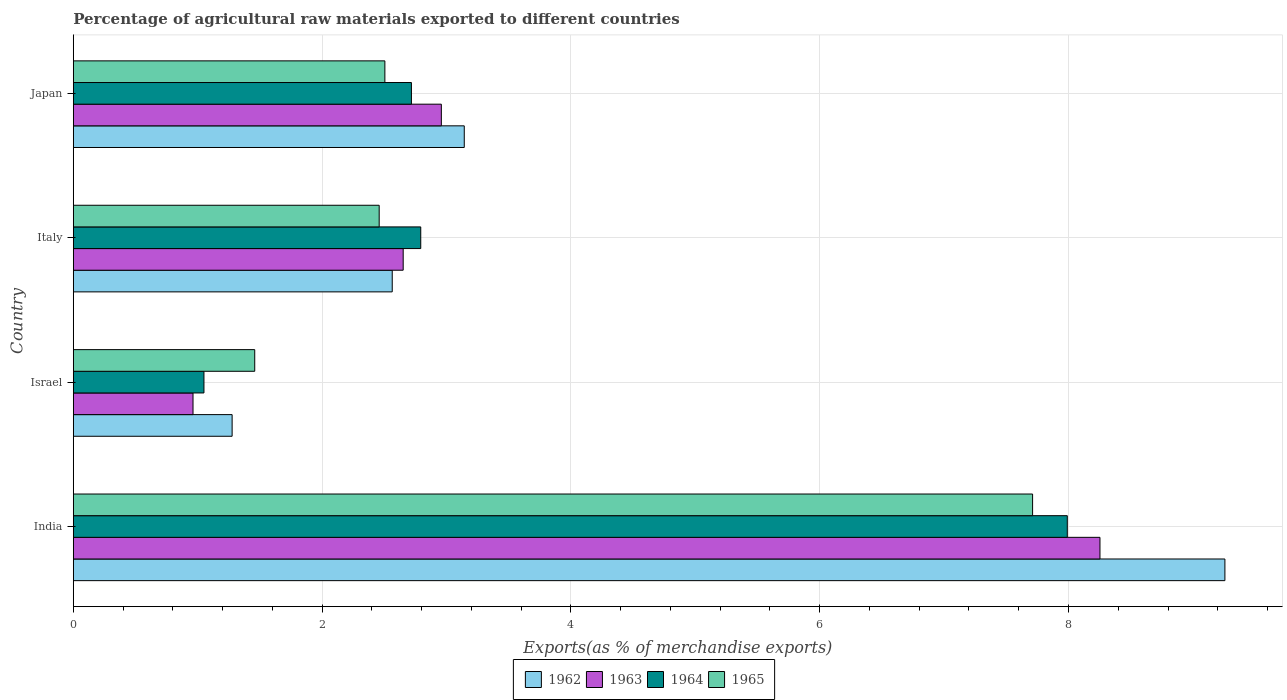How many groups of bars are there?
Give a very brief answer. 4. Are the number of bars on each tick of the Y-axis equal?
Your response must be concise. Yes. What is the label of the 2nd group of bars from the top?
Keep it short and to the point. Italy. What is the percentage of exports to different countries in 1964 in Israel?
Your answer should be compact. 1.05. Across all countries, what is the maximum percentage of exports to different countries in 1965?
Your answer should be very brief. 7.71. Across all countries, what is the minimum percentage of exports to different countries in 1963?
Provide a short and direct response. 0.96. In which country was the percentage of exports to different countries in 1964 maximum?
Offer a terse response. India. In which country was the percentage of exports to different countries in 1963 minimum?
Your answer should be very brief. Israel. What is the total percentage of exports to different countries in 1962 in the graph?
Your response must be concise. 16.24. What is the difference between the percentage of exports to different countries in 1965 in Israel and that in Italy?
Your response must be concise. -1. What is the difference between the percentage of exports to different countries in 1963 in Japan and the percentage of exports to different countries in 1962 in Israel?
Ensure brevity in your answer.  1.68. What is the average percentage of exports to different countries in 1964 per country?
Provide a succinct answer. 3.64. What is the difference between the percentage of exports to different countries in 1963 and percentage of exports to different countries in 1964 in India?
Provide a short and direct response. 0.26. In how many countries, is the percentage of exports to different countries in 1964 greater than 8.4 %?
Your response must be concise. 0. What is the ratio of the percentage of exports to different countries in 1964 in Israel to that in Italy?
Your answer should be very brief. 0.38. Is the difference between the percentage of exports to different countries in 1963 in Italy and Japan greater than the difference between the percentage of exports to different countries in 1964 in Italy and Japan?
Offer a terse response. No. What is the difference between the highest and the second highest percentage of exports to different countries in 1964?
Give a very brief answer. 5.2. What is the difference between the highest and the lowest percentage of exports to different countries in 1962?
Your answer should be compact. 7.98. In how many countries, is the percentage of exports to different countries in 1962 greater than the average percentage of exports to different countries in 1962 taken over all countries?
Provide a short and direct response. 1. Is the sum of the percentage of exports to different countries in 1963 in India and Israel greater than the maximum percentage of exports to different countries in 1964 across all countries?
Keep it short and to the point. Yes. What does the 2nd bar from the top in Japan represents?
Provide a short and direct response. 1964. Is it the case that in every country, the sum of the percentage of exports to different countries in 1963 and percentage of exports to different countries in 1964 is greater than the percentage of exports to different countries in 1965?
Keep it short and to the point. Yes. Are all the bars in the graph horizontal?
Ensure brevity in your answer.  Yes. How many countries are there in the graph?
Your response must be concise. 4. What is the difference between two consecutive major ticks on the X-axis?
Provide a succinct answer. 2. Does the graph contain any zero values?
Offer a very short reply. No. Where does the legend appear in the graph?
Make the answer very short. Bottom center. How many legend labels are there?
Ensure brevity in your answer.  4. What is the title of the graph?
Keep it short and to the point. Percentage of agricultural raw materials exported to different countries. Does "1985" appear as one of the legend labels in the graph?
Your response must be concise. No. What is the label or title of the X-axis?
Give a very brief answer. Exports(as % of merchandise exports). What is the Exports(as % of merchandise exports) in 1962 in India?
Make the answer very short. 9.26. What is the Exports(as % of merchandise exports) of 1963 in India?
Your answer should be compact. 8.25. What is the Exports(as % of merchandise exports) of 1964 in India?
Your answer should be compact. 7.99. What is the Exports(as % of merchandise exports) of 1965 in India?
Offer a terse response. 7.71. What is the Exports(as % of merchandise exports) in 1962 in Israel?
Make the answer very short. 1.28. What is the Exports(as % of merchandise exports) of 1963 in Israel?
Your answer should be compact. 0.96. What is the Exports(as % of merchandise exports) in 1964 in Israel?
Offer a very short reply. 1.05. What is the Exports(as % of merchandise exports) in 1965 in Israel?
Offer a terse response. 1.46. What is the Exports(as % of merchandise exports) of 1962 in Italy?
Offer a very short reply. 2.56. What is the Exports(as % of merchandise exports) of 1963 in Italy?
Keep it short and to the point. 2.65. What is the Exports(as % of merchandise exports) in 1964 in Italy?
Keep it short and to the point. 2.79. What is the Exports(as % of merchandise exports) in 1965 in Italy?
Provide a succinct answer. 2.46. What is the Exports(as % of merchandise exports) in 1962 in Japan?
Offer a very short reply. 3.14. What is the Exports(as % of merchandise exports) of 1963 in Japan?
Keep it short and to the point. 2.96. What is the Exports(as % of merchandise exports) in 1964 in Japan?
Give a very brief answer. 2.72. What is the Exports(as % of merchandise exports) of 1965 in Japan?
Make the answer very short. 2.5. Across all countries, what is the maximum Exports(as % of merchandise exports) in 1962?
Your answer should be very brief. 9.26. Across all countries, what is the maximum Exports(as % of merchandise exports) of 1963?
Your response must be concise. 8.25. Across all countries, what is the maximum Exports(as % of merchandise exports) of 1964?
Make the answer very short. 7.99. Across all countries, what is the maximum Exports(as % of merchandise exports) in 1965?
Make the answer very short. 7.71. Across all countries, what is the minimum Exports(as % of merchandise exports) of 1962?
Your response must be concise. 1.28. Across all countries, what is the minimum Exports(as % of merchandise exports) in 1963?
Your response must be concise. 0.96. Across all countries, what is the minimum Exports(as % of merchandise exports) of 1964?
Provide a succinct answer. 1.05. Across all countries, what is the minimum Exports(as % of merchandise exports) in 1965?
Ensure brevity in your answer.  1.46. What is the total Exports(as % of merchandise exports) of 1962 in the graph?
Offer a terse response. 16.24. What is the total Exports(as % of merchandise exports) in 1963 in the graph?
Make the answer very short. 14.83. What is the total Exports(as % of merchandise exports) in 1964 in the graph?
Your response must be concise. 14.55. What is the total Exports(as % of merchandise exports) in 1965 in the graph?
Ensure brevity in your answer.  14.13. What is the difference between the Exports(as % of merchandise exports) of 1962 in India and that in Israel?
Ensure brevity in your answer.  7.98. What is the difference between the Exports(as % of merchandise exports) in 1963 in India and that in Israel?
Offer a very short reply. 7.29. What is the difference between the Exports(as % of merchandise exports) in 1964 in India and that in Israel?
Offer a terse response. 6.94. What is the difference between the Exports(as % of merchandise exports) of 1965 in India and that in Israel?
Offer a terse response. 6.25. What is the difference between the Exports(as % of merchandise exports) of 1962 in India and that in Italy?
Make the answer very short. 6.69. What is the difference between the Exports(as % of merchandise exports) in 1963 in India and that in Italy?
Ensure brevity in your answer.  5.6. What is the difference between the Exports(as % of merchandise exports) in 1964 in India and that in Italy?
Offer a terse response. 5.2. What is the difference between the Exports(as % of merchandise exports) in 1965 in India and that in Italy?
Give a very brief answer. 5.25. What is the difference between the Exports(as % of merchandise exports) of 1962 in India and that in Japan?
Provide a succinct answer. 6.11. What is the difference between the Exports(as % of merchandise exports) of 1963 in India and that in Japan?
Keep it short and to the point. 5.29. What is the difference between the Exports(as % of merchandise exports) of 1964 in India and that in Japan?
Make the answer very short. 5.27. What is the difference between the Exports(as % of merchandise exports) in 1965 in India and that in Japan?
Your response must be concise. 5.21. What is the difference between the Exports(as % of merchandise exports) of 1962 in Israel and that in Italy?
Offer a very short reply. -1.29. What is the difference between the Exports(as % of merchandise exports) of 1963 in Israel and that in Italy?
Provide a short and direct response. -1.69. What is the difference between the Exports(as % of merchandise exports) in 1964 in Israel and that in Italy?
Offer a very short reply. -1.74. What is the difference between the Exports(as % of merchandise exports) in 1965 in Israel and that in Italy?
Keep it short and to the point. -1. What is the difference between the Exports(as % of merchandise exports) in 1962 in Israel and that in Japan?
Offer a terse response. -1.87. What is the difference between the Exports(as % of merchandise exports) of 1963 in Israel and that in Japan?
Ensure brevity in your answer.  -2. What is the difference between the Exports(as % of merchandise exports) of 1964 in Israel and that in Japan?
Provide a short and direct response. -1.67. What is the difference between the Exports(as % of merchandise exports) in 1965 in Israel and that in Japan?
Provide a short and direct response. -1.05. What is the difference between the Exports(as % of merchandise exports) of 1962 in Italy and that in Japan?
Your response must be concise. -0.58. What is the difference between the Exports(as % of merchandise exports) in 1963 in Italy and that in Japan?
Give a very brief answer. -0.31. What is the difference between the Exports(as % of merchandise exports) in 1964 in Italy and that in Japan?
Make the answer very short. 0.07. What is the difference between the Exports(as % of merchandise exports) in 1965 in Italy and that in Japan?
Provide a short and direct response. -0.05. What is the difference between the Exports(as % of merchandise exports) of 1962 in India and the Exports(as % of merchandise exports) of 1963 in Israel?
Give a very brief answer. 8.3. What is the difference between the Exports(as % of merchandise exports) of 1962 in India and the Exports(as % of merchandise exports) of 1964 in Israel?
Offer a very short reply. 8.21. What is the difference between the Exports(as % of merchandise exports) of 1962 in India and the Exports(as % of merchandise exports) of 1965 in Israel?
Make the answer very short. 7.8. What is the difference between the Exports(as % of merchandise exports) of 1963 in India and the Exports(as % of merchandise exports) of 1964 in Israel?
Your response must be concise. 7.2. What is the difference between the Exports(as % of merchandise exports) of 1963 in India and the Exports(as % of merchandise exports) of 1965 in Israel?
Make the answer very short. 6.79. What is the difference between the Exports(as % of merchandise exports) in 1964 in India and the Exports(as % of merchandise exports) in 1965 in Israel?
Ensure brevity in your answer.  6.53. What is the difference between the Exports(as % of merchandise exports) of 1962 in India and the Exports(as % of merchandise exports) of 1963 in Italy?
Your answer should be compact. 6.61. What is the difference between the Exports(as % of merchandise exports) in 1962 in India and the Exports(as % of merchandise exports) in 1964 in Italy?
Offer a terse response. 6.46. What is the difference between the Exports(as % of merchandise exports) of 1962 in India and the Exports(as % of merchandise exports) of 1965 in Italy?
Keep it short and to the point. 6.8. What is the difference between the Exports(as % of merchandise exports) in 1963 in India and the Exports(as % of merchandise exports) in 1964 in Italy?
Provide a short and direct response. 5.46. What is the difference between the Exports(as % of merchandise exports) in 1963 in India and the Exports(as % of merchandise exports) in 1965 in Italy?
Offer a very short reply. 5.79. What is the difference between the Exports(as % of merchandise exports) in 1964 in India and the Exports(as % of merchandise exports) in 1965 in Italy?
Your answer should be compact. 5.53. What is the difference between the Exports(as % of merchandise exports) in 1962 in India and the Exports(as % of merchandise exports) in 1963 in Japan?
Provide a short and direct response. 6.3. What is the difference between the Exports(as % of merchandise exports) in 1962 in India and the Exports(as % of merchandise exports) in 1964 in Japan?
Offer a terse response. 6.54. What is the difference between the Exports(as % of merchandise exports) of 1962 in India and the Exports(as % of merchandise exports) of 1965 in Japan?
Give a very brief answer. 6.75. What is the difference between the Exports(as % of merchandise exports) of 1963 in India and the Exports(as % of merchandise exports) of 1964 in Japan?
Provide a succinct answer. 5.54. What is the difference between the Exports(as % of merchandise exports) in 1963 in India and the Exports(as % of merchandise exports) in 1965 in Japan?
Your answer should be compact. 5.75. What is the difference between the Exports(as % of merchandise exports) of 1964 in India and the Exports(as % of merchandise exports) of 1965 in Japan?
Offer a very short reply. 5.49. What is the difference between the Exports(as % of merchandise exports) of 1962 in Israel and the Exports(as % of merchandise exports) of 1963 in Italy?
Your answer should be very brief. -1.38. What is the difference between the Exports(as % of merchandise exports) of 1962 in Israel and the Exports(as % of merchandise exports) of 1964 in Italy?
Offer a terse response. -1.52. What is the difference between the Exports(as % of merchandise exports) in 1962 in Israel and the Exports(as % of merchandise exports) in 1965 in Italy?
Offer a terse response. -1.18. What is the difference between the Exports(as % of merchandise exports) in 1963 in Israel and the Exports(as % of merchandise exports) in 1964 in Italy?
Your response must be concise. -1.83. What is the difference between the Exports(as % of merchandise exports) of 1963 in Israel and the Exports(as % of merchandise exports) of 1965 in Italy?
Your response must be concise. -1.5. What is the difference between the Exports(as % of merchandise exports) of 1964 in Israel and the Exports(as % of merchandise exports) of 1965 in Italy?
Provide a short and direct response. -1.41. What is the difference between the Exports(as % of merchandise exports) in 1962 in Israel and the Exports(as % of merchandise exports) in 1963 in Japan?
Make the answer very short. -1.68. What is the difference between the Exports(as % of merchandise exports) of 1962 in Israel and the Exports(as % of merchandise exports) of 1964 in Japan?
Keep it short and to the point. -1.44. What is the difference between the Exports(as % of merchandise exports) of 1962 in Israel and the Exports(as % of merchandise exports) of 1965 in Japan?
Ensure brevity in your answer.  -1.23. What is the difference between the Exports(as % of merchandise exports) in 1963 in Israel and the Exports(as % of merchandise exports) in 1964 in Japan?
Make the answer very short. -1.76. What is the difference between the Exports(as % of merchandise exports) in 1963 in Israel and the Exports(as % of merchandise exports) in 1965 in Japan?
Offer a terse response. -1.54. What is the difference between the Exports(as % of merchandise exports) in 1964 in Israel and the Exports(as % of merchandise exports) in 1965 in Japan?
Provide a succinct answer. -1.45. What is the difference between the Exports(as % of merchandise exports) of 1962 in Italy and the Exports(as % of merchandise exports) of 1963 in Japan?
Your answer should be compact. -0.39. What is the difference between the Exports(as % of merchandise exports) of 1962 in Italy and the Exports(as % of merchandise exports) of 1964 in Japan?
Offer a very short reply. -0.15. What is the difference between the Exports(as % of merchandise exports) in 1962 in Italy and the Exports(as % of merchandise exports) in 1965 in Japan?
Provide a succinct answer. 0.06. What is the difference between the Exports(as % of merchandise exports) of 1963 in Italy and the Exports(as % of merchandise exports) of 1964 in Japan?
Offer a terse response. -0.07. What is the difference between the Exports(as % of merchandise exports) of 1963 in Italy and the Exports(as % of merchandise exports) of 1965 in Japan?
Your answer should be compact. 0.15. What is the difference between the Exports(as % of merchandise exports) in 1964 in Italy and the Exports(as % of merchandise exports) in 1965 in Japan?
Your answer should be compact. 0.29. What is the average Exports(as % of merchandise exports) of 1962 per country?
Offer a very short reply. 4.06. What is the average Exports(as % of merchandise exports) of 1963 per country?
Provide a succinct answer. 3.71. What is the average Exports(as % of merchandise exports) in 1964 per country?
Keep it short and to the point. 3.64. What is the average Exports(as % of merchandise exports) in 1965 per country?
Provide a short and direct response. 3.53. What is the difference between the Exports(as % of merchandise exports) of 1962 and Exports(as % of merchandise exports) of 1963 in India?
Provide a succinct answer. 1. What is the difference between the Exports(as % of merchandise exports) in 1962 and Exports(as % of merchandise exports) in 1964 in India?
Offer a very short reply. 1.27. What is the difference between the Exports(as % of merchandise exports) in 1962 and Exports(as % of merchandise exports) in 1965 in India?
Keep it short and to the point. 1.55. What is the difference between the Exports(as % of merchandise exports) of 1963 and Exports(as % of merchandise exports) of 1964 in India?
Make the answer very short. 0.26. What is the difference between the Exports(as % of merchandise exports) of 1963 and Exports(as % of merchandise exports) of 1965 in India?
Your answer should be very brief. 0.54. What is the difference between the Exports(as % of merchandise exports) of 1964 and Exports(as % of merchandise exports) of 1965 in India?
Provide a short and direct response. 0.28. What is the difference between the Exports(as % of merchandise exports) of 1962 and Exports(as % of merchandise exports) of 1963 in Israel?
Your answer should be very brief. 0.31. What is the difference between the Exports(as % of merchandise exports) in 1962 and Exports(as % of merchandise exports) in 1964 in Israel?
Your answer should be very brief. 0.23. What is the difference between the Exports(as % of merchandise exports) in 1962 and Exports(as % of merchandise exports) in 1965 in Israel?
Provide a succinct answer. -0.18. What is the difference between the Exports(as % of merchandise exports) of 1963 and Exports(as % of merchandise exports) of 1964 in Israel?
Provide a short and direct response. -0.09. What is the difference between the Exports(as % of merchandise exports) of 1963 and Exports(as % of merchandise exports) of 1965 in Israel?
Keep it short and to the point. -0.5. What is the difference between the Exports(as % of merchandise exports) in 1964 and Exports(as % of merchandise exports) in 1965 in Israel?
Offer a terse response. -0.41. What is the difference between the Exports(as % of merchandise exports) in 1962 and Exports(as % of merchandise exports) in 1963 in Italy?
Offer a terse response. -0.09. What is the difference between the Exports(as % of merchandise exports) of 1962 and Exports(as % of merchandise exports) of 1964 in Italy?
Provide a succinct answer. -0.23. What is the difference between the Exports(as % of merchandise exports) of 1962 and Exports(as % of merchandise exports) of 1965 in Italy?
Offer a very short reply. 0.1. What is the difference between the Exports(as % of merchandise exports) in 1963 and Exports(as % of merchandise exports) in 1964 in Italy?
Offer a terse response. -0.14. What is the difference between the Exports(as % of merchandise exports) of 1963 and Exports(as % of merchandise exports) of 1965 in Italy?
Your response must be concise. 0.19. What is the difference between the Exports(as % of merchandise exports) in 1964 and Exports(as % of merchandise exports) in 1965 in Italy?
Make the answer very short. 0.33. What is the difference between the Exports(as % of merchandise exports) of 1962 and Exports(as % of merchandise exports) of 1963 in Japan?
Your answer should be very brief. 0.18. What is the difference between the Exports(as % of merchandise exports) in 1962 and Exports(as % of merchandise exports) in 1964 in Japan?
Make the answer very short. 0.42. What is the difference between the Exports(as % of merchandise exports) of 1962 and Exports(as % of merchandise exports) of 1965 in Japan?
Offer a very short reply. 0.64. What is the difference between the Exports(as % of merchandise exports) of 1963 and Exports(as % of merchandise exports) of 1964 in Japan?
Make the answer very short. 0.24. What is the difference between the Exports(as % of merchandise exports) in 1963 and Exports(as % of merchandise exports) in 1965 in Japan?
Offer a terse response. 0.45. What is the difference between the Exports(as % of merchandise exports) in 1964 and Exports(as % of merchandise exports) in 1965 in Japan?
Keep it short and to the point. 0.21. What is the ratio of the Exports(as % of merchandise exports) in 1962 in India to that in Israel?
Your answer should be compact. 7.25. What is the ratio of the Exports(as % of merchandise exports) of 1963 in India to that in Israel?
Give a very brief answer. 8.58. What is the ratio of the Exports(as % of merchandise exports) in 1964 in India to that in Israel?
Ensure brevity in your answer.  7.61. What is the ratio of the Exports(as % of merchandise exports) of 1965 in India to that in Israel?
Keep it short and to the point. 5.29. What is the ratio of the Exports(as % of merchandise exports) in 1962 in India to that in Italy?
Provide a succinct answer. 3.61. What is the ratio of the Exports(as % of merchandise exports) in 1963 in India to that in Italy?
Your answer should be very brief. 3.11. What is the ratio of the Exports(as % of merchandise exports) in 1964 in India to that in Italy?
Make the answer very short. 2.86. What is the ratio of the Exports(as % of merchandise exports) in 1965 in India to that in Italy?
Make the answer very short. 3.14. What is the ratio of the Exports(as % of merchandise exports) in 1962 in India to that in Japan?
Your answer should be compact. 2.95. What is the ratio of the Exports(as % of merchandise exports) of 1963 in India to that in Japan?
Provide a short and direct response. 2.79. What is the ratio of the Exports(as % of merchandise exports) in 1964 in India to that in Japan?
Your answer should be compact. 2.94. What is the ratio of the Exports(as % of merchandise exports) in 1965 in India to that in Japan?
Make the answer very short. 3.08. What is the ratio of the Exports(as % of merchandise exports) in 1962 in Israel to that in Italy?
Your answer should be very brief. 0.5. What is the ratio of the Exports(as % of merchandise exports) in 1963 in Israel to that in Italy?
Give a very brief answer. 0.36. What is the ratio of the Exports(as % of merchandise exports) of 1964 in Israel to that in Italy?
Keep it short and to the point. 0.38. What is the ratio of the Exports(as % of merchandise exports) in 1965 in Israel to that in Italy?
Your response must be concise. 0.59. What is the ratio of the Exports(as % of merchandise exports) in 1962 in Israel to that in Japan?
Make the answer very short. 0.41. What is the ratio of the Exports(as % of merchandise exports) in 1963 in Israel to that in Japan?
Keep it short and to the point. 0.33. What is the ratio of the Exports(as % of merchandise exports) in 1964 in Israel to that in Japan?
Keep it short and to the point. 0.39. What is the ratio of the Exports(as % of merchandise exports) in 1965 in Israel to that in Japan?
Provide a succinct answer. 0.58. What is the ratio of the Exports(as % of merchandise exports) in 1962 in Italy to that in Japan?
Offer a very short reply. 0.82. What is the ratio of the Exports(as % of merchandise exports) of 1963 in Italy to that in Japan?
Your answer should be compact. 0.9. What is the ratio of the Exports(as % of merchandise exports) in 1964 in Italy to that in Japan?
Offer a very short reply. 1.03. What is the ratio of the Exports(as % of merchandise exports) of 1965 in Italy to that in Japan?
Your answer should be compact. 0.98. What is the difference between the highest and the second highest Exports(as % of merchandise exports) of 1962?
Keep it short and to the point. 6.11. What is the difference between the highest and the second highest Exports(as % of merchandise exports) in 1963?
Ensure brevity in your answer.  5.29. What is the difference between the highest and the second highest Exports(as % of merchandise exports) of 1964?
Your response must be concise. 5.2. What is the difference between the highest and the second highest Exports(as % of merchandise exports) in 1965?
Ensure brevity in your answer.  5.21. What is the difference between the highest and the lowest Exports(as % of merchandise exports) of 1962?
Your answer should be compact. 7.98. What is the difference between the highest and the lowest Exports(as % of merchandise exports) of 1963?
Keep it short and to the point. 7.29. What is the difference between the highest and the lowest Exports(as % of merchandise exports) in 1964?
Your answer should be compact. 6.94. What is the difference between the highest and the lowest Exports(as % of merchandise exports) in 1965?
Your answer should be compact. 6.25. 